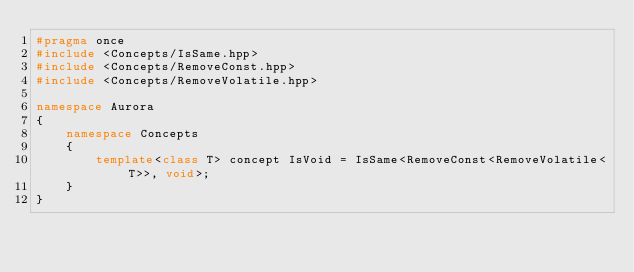Convert code to text. <code><loc_0><loc_0><loc_500><loc_500><_C++_>#pragma once
#include <Concepts/IsSame.hpp>
#include <Concepts/RemoveConst.hpp>
#include <Concepts/RemoveVolatile.hpp>

namespace Aurora
{
    namespace Concepts
    {
        template<class T> concept IsVoid = IsSame<RemoveConst<RemoveVolatile<T>>, void>;
    }
}</code> 